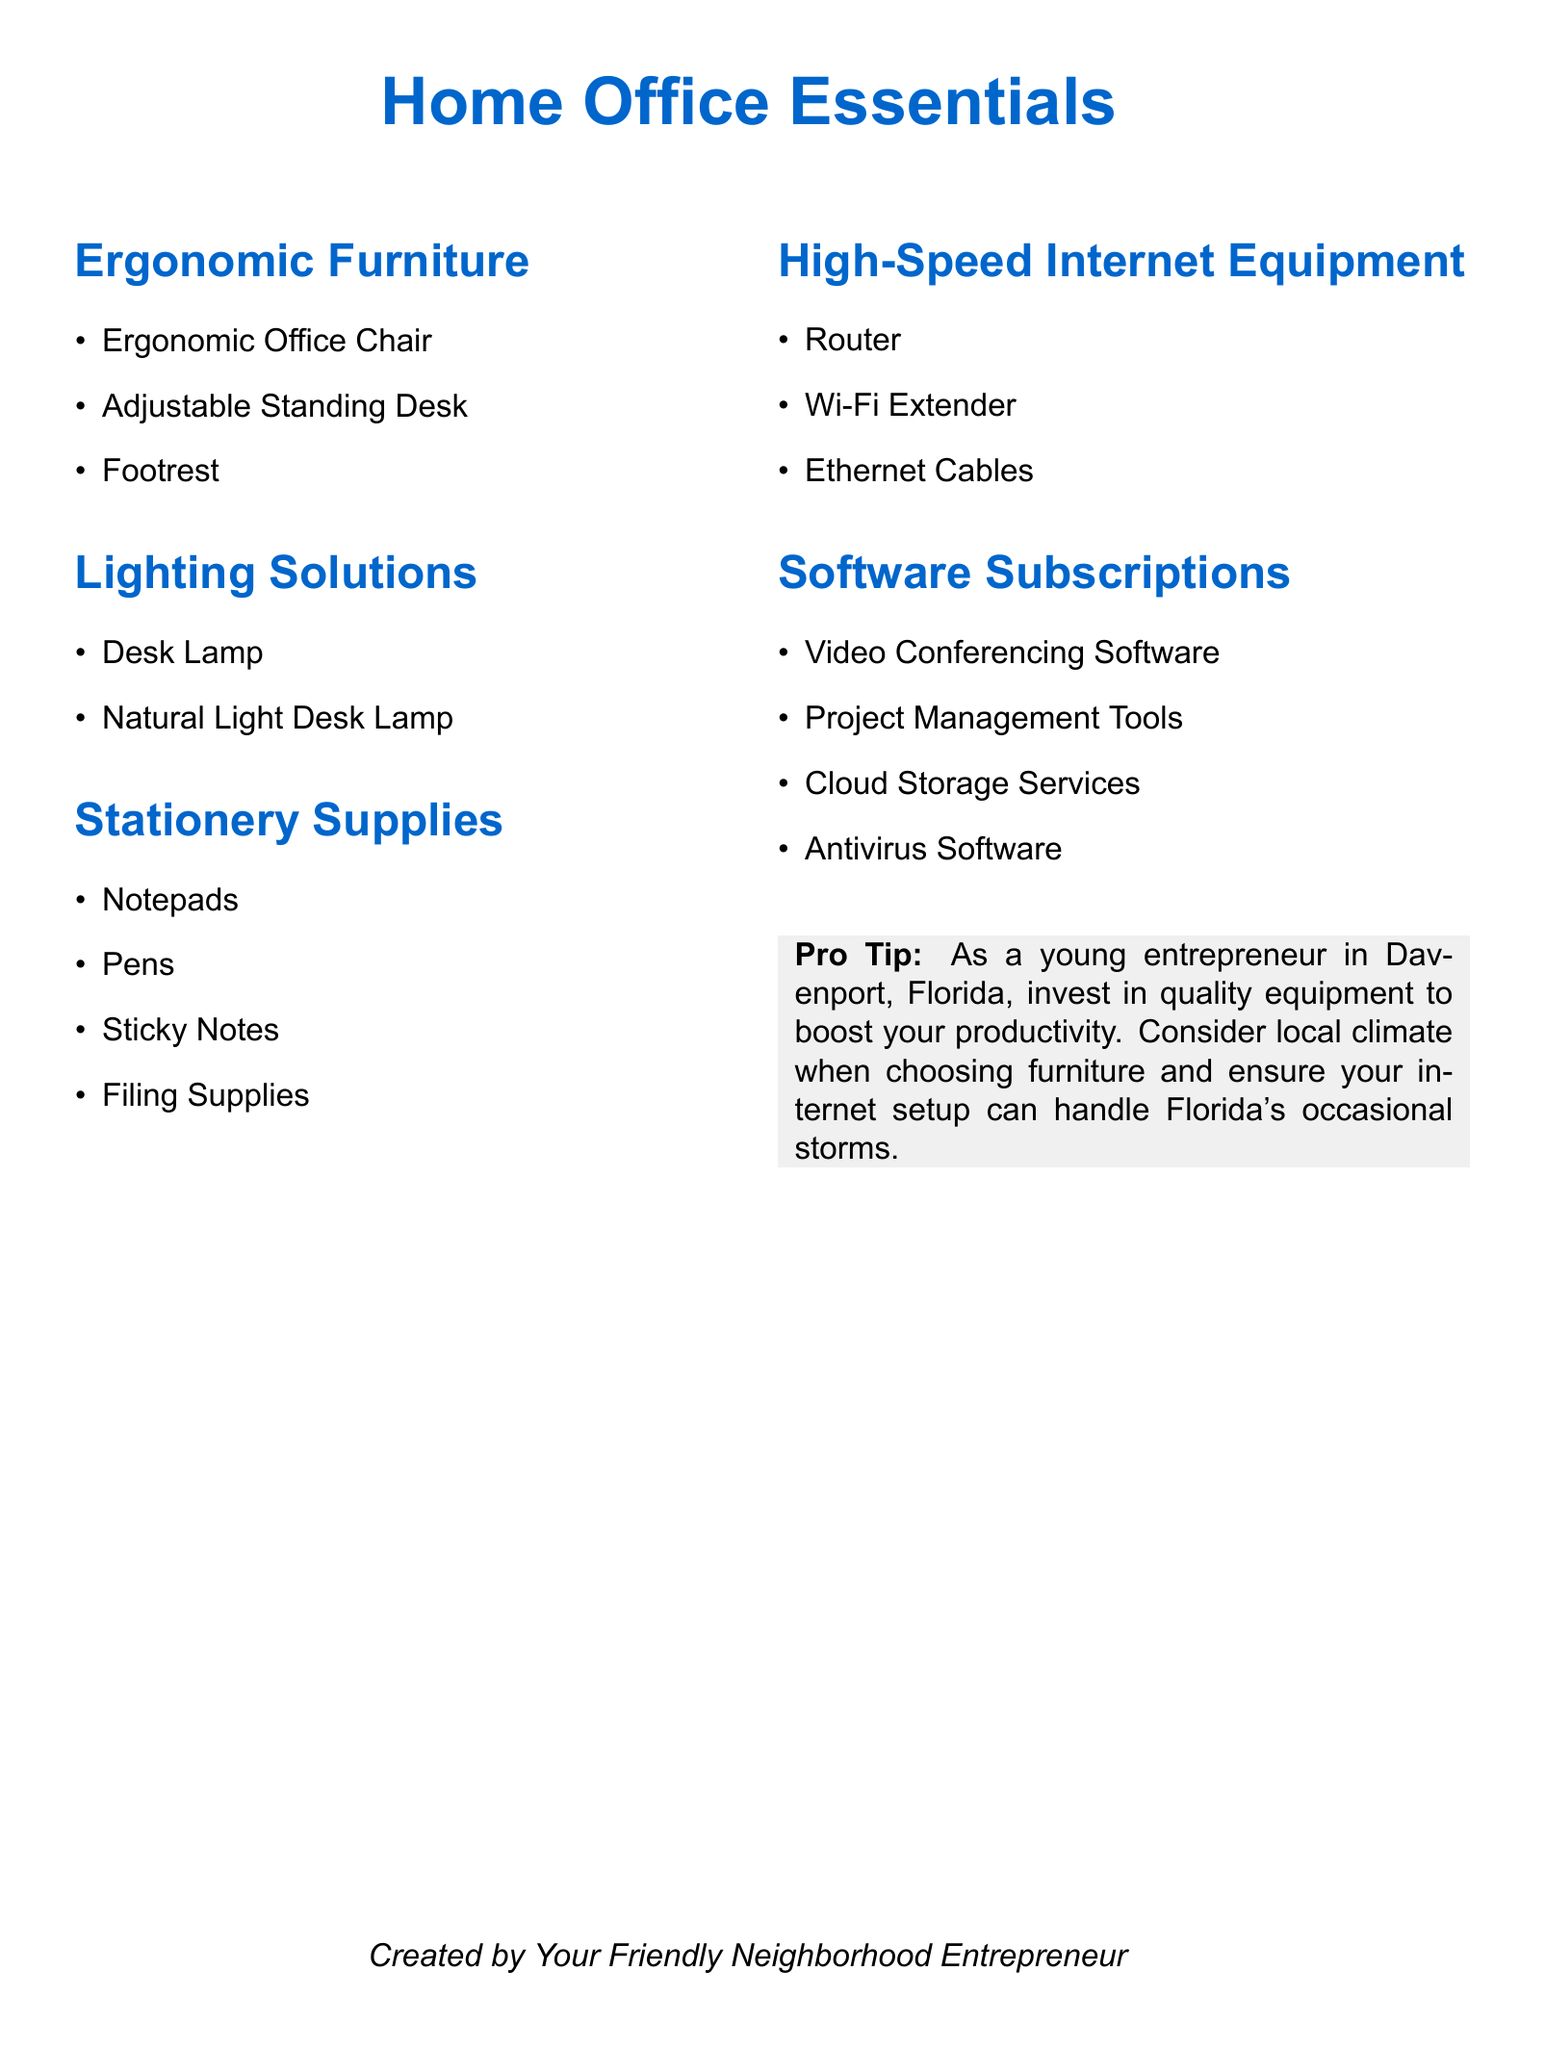What items are listed under ergonomic furniture? The document lists ergonomic office chair, adjustable standing desk, and footrest under the ergonomic furniture section.
Answer: Ergonomic office chair, adjustable standing desk, footrest How many types of lighting solutions are mentioned? The document mentions two types of lighting solutions: desk lamp and natural light desk lamp.
Answer: Two What are the stationery supplies included in the list? The stationery supplies listed in the document are notepads, pens, sticky notes, and filing supplies.
Answer: Notepads, pens, sticky notes, filing supplies What is the first item listed in high-speed internet equipment? The first item listed under high-speed internet equipment is router.
Answer: Router Which software subscription is geared towards remote communication? The subscription intended for remote communication mentioned in the document is video conferencing software.
Answer: Video conferencing software What is one recommended investment for boosting productivity? The document suggests investing in quality equipment to boost productivity, particularly for young entrepreneurs.
Answer: Quality equipment What color is the tip box in the document? The color of the tip box in the document is gray.
Answer: Gray How does the document suggest considering local conditions in your home office setup? The document advises taking into account the local climate when choosing furniture and ensuring the internet setup can handle Florida's occasional storms.
Answer: Local climate 